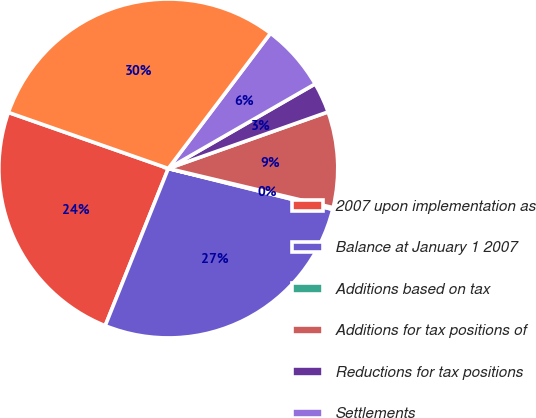<chart> <loc_0><loc_0><loc_500><loc_500><pie_chart><fcel>2007 upon implementation as<fcel>Balance at January 1 2007<fcel>Additions based on tax<fcel>Additions for tax positions of<fcel>Reductions for tax positions<fcel>Settlements<fcel>Balance at December 31 2007<nl><fcel>24.29%<fcel>27.19%<fcel>0.17%<fcel>9.13%<fcel>2.9%<fcel>6.39%<fcel>29.93%<nl></chart> 